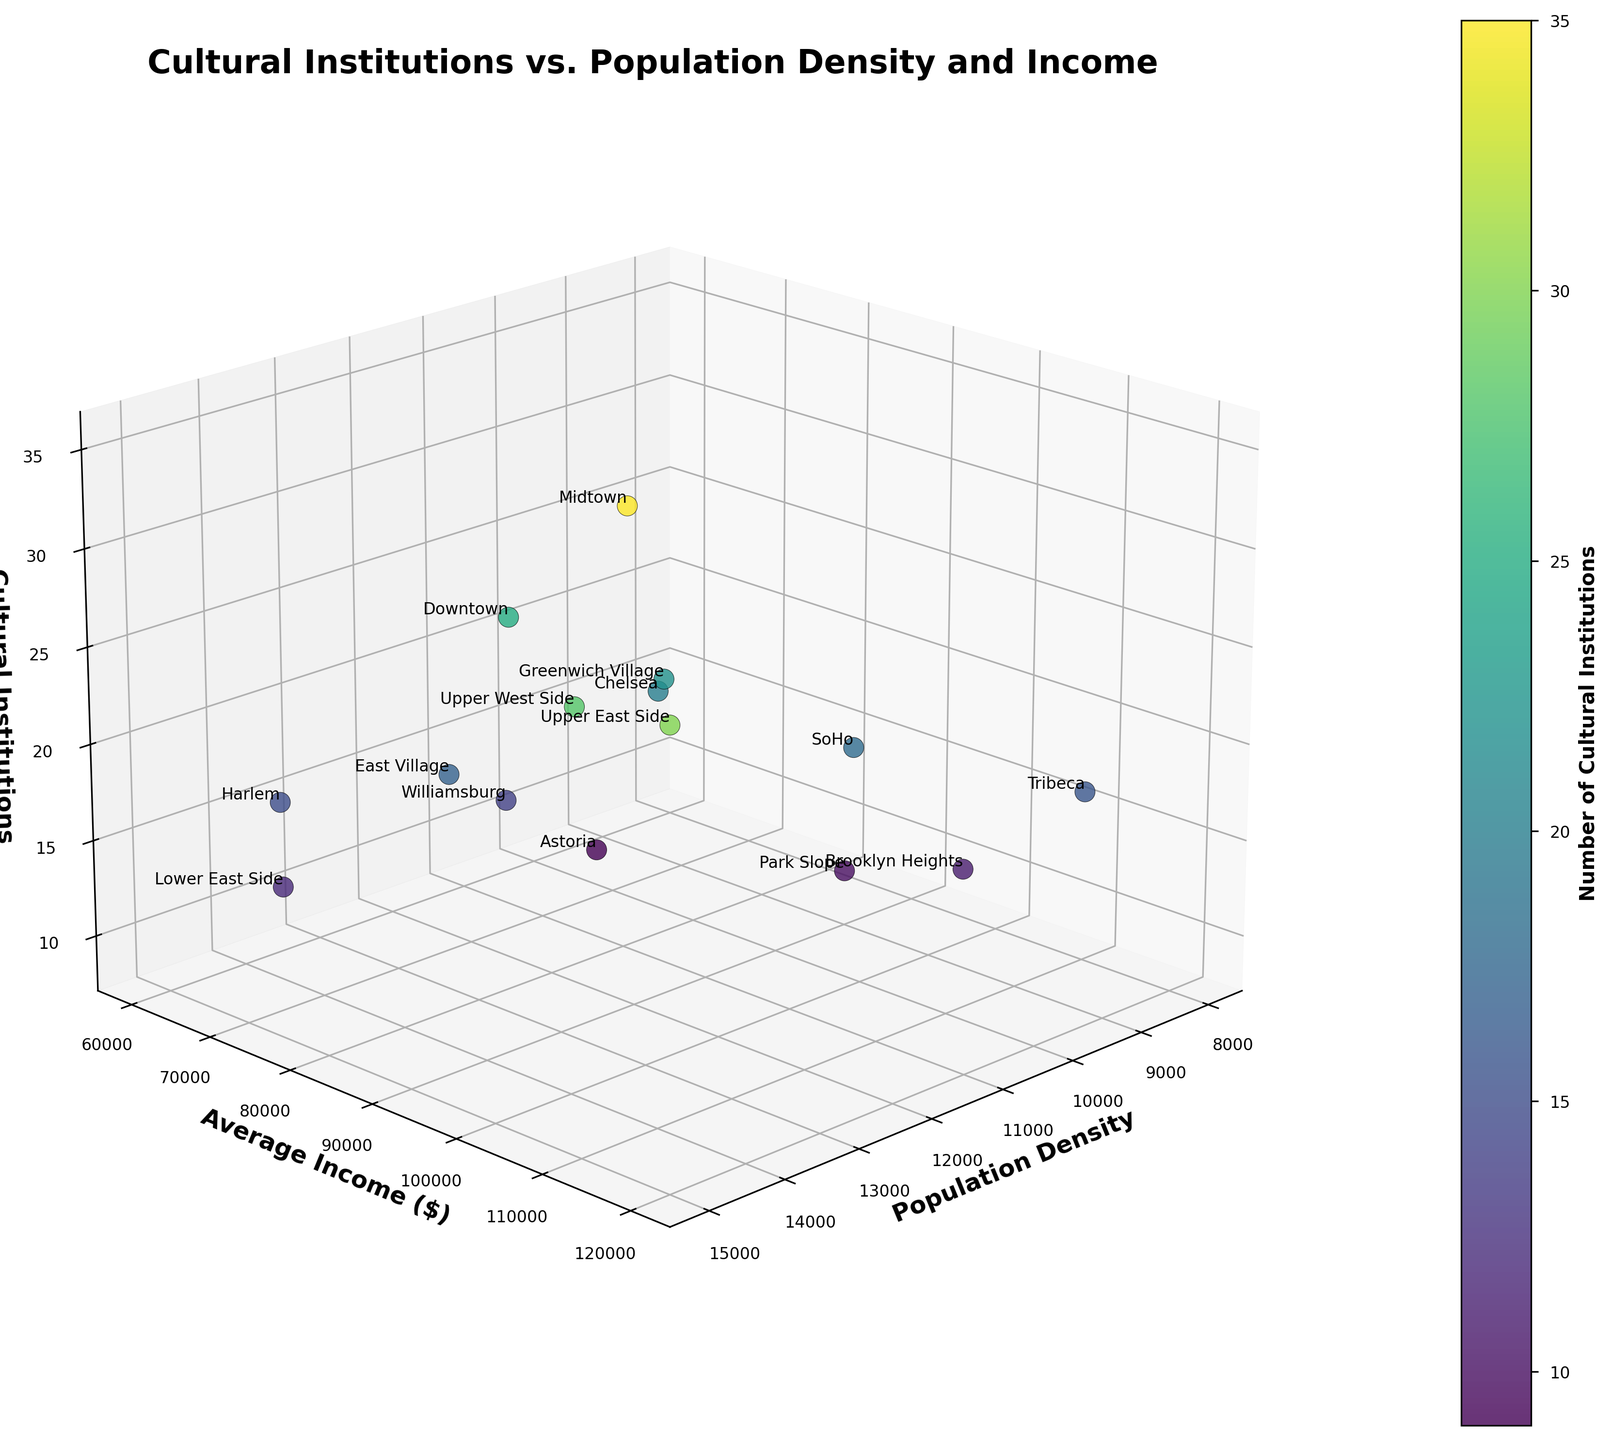What's the title of the figure? The title of the figure is typically found at the top and describes what the figure is about. In this case, it reads "Cultural Institutions vs. Population Density and Income".
Answer: Cultural Institutions vs. Population Density and Income Which axis represents the number of Cultural Institutions? The z-axis is labeled with "Cultural Institutions", indicating it represents the number of Cultural Institutions.
Answer: The z-axis Which neighborhood has the most cultural institutions? By examining the z-axis values and the labeled data points, Midtown shows the highest value for cultural institutions at 35.
Answer: Midtown How many cultural institutions are there in Chelsea? Locate the data point labeled "Chelsea" and check its z-axis value. Chelsea has 20 cultural institutions.
Answer: 20 What is the highest population density shown in the figure? Look at the x-axis which represents population density. The Upper East Side shows the highest population density at 15,000.
Answer: 15,000 Which neighborhood has the lowest number of cultural institutions, and what is its average income? Find the data point with the lowest z-axis value and check its y-axis value for average income. Astoria has the lowest cultural institutions (9) and an average income of $68,000.
Answer: Astoria, $68,000 Which neighborhood has a lower population density but a higher average income compared to Harlem? Compare the x and y axis values of Harlem with other neighborhoods. Tribeca has a population density of 8,000 (lower than Harlem’s 13,500) and an average income of $110,000 (higher than Harlem’s $60,000).
Answer: Tribeca What is the difference in cultural institutions between Downtown and SoHo? Subtract the number of cultural institutions in SoHo from Downtown. Downtown has 25 and SoHo has 18. Thus, the difference is 25 - 18 = 7.
Answer: 7 Which neighborhoods have cultural institutions numbering more than 25? Look for neighborhoods whose data points on the z-axis are above 25. The neighborhoods are Downtown, Upper East Side, Upper West Side, and Midtown.
Answer: Downtown, Upper East Side, Upper West Side, Midtown Considering both average income and the number of cultural institutions, which neighborhood has the least favorable combination? Compare the neighborhoods for the lowest values in both y and z axes. The Lower East Side has a relatively low income ($65,000) and a low number of cultural institutions (12).
Answer: Lower East Side 